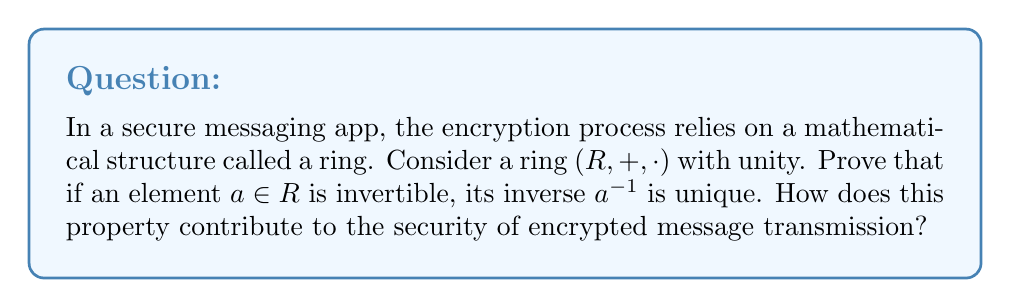Solve this math problem. Let's approach this proof step-by-step:

1) First, let's assume that $a \in R$ is invertible. This means there exists an element $b \in R$ such that $ab = ba = 1$, where $1$ is the multiplicative identity in $R$.

2) Now, let's suppose that $a$ has two inverses, call them $b$ and $c$. We need to prove that $b = c$.

3) Since $b$ is an inverse of $a$, we have:
   $ab = ba = 1$

4) Similarly, since $c$ is also an inverse of $a$:
   $ac = ca = 1$

5) Now, let's consider the product $b \cdot 1$:
   $b \cdot 1 = b \cdot (ac)$ (substituting $1$ with $ac$ from step 4)
              $= (b \cdot a) \cdot c$ (using associativity of multiplication in rings)
              $= 1 \cdot c$ (using $ba = 1$ from step 3)
              $= c$

6) Therefore, $b = c$, proving that the inverse is unique.

This uniqueness property is crucial for secure message transmission in several ways:

a) Encryption Reliability: In many encryption algorithms, the inverse operation is used for decryption. The uniqueness of inverses ensures that there's only one way to decrypt a message, preventing ambiguity.

b) Key Generation: In public-key cryptography systems often used in secure messaging, the generation of public and private keys relies on the properties of certain mathematical structures. The uniqueness of inverses in these structures ensures that each public key corresponds to exactly one private key.

c) Digital Signatures: The uniqueness of inverses is also crucial for digital signature schemes, which are often used to verify the authenticity of messages in secure communication systems.

d) Error Detection: In some cryptographic protocols, the uniqueness of inverses can be used to detect errors in transmission or tampering attempts.

For a product manager overseeing the integration of encryption in a messaging app, understanding this property helps in making informed decisions about the choice of cryptographic algorithms and in communicating the security features to users and stakeholders.
Answer: The inverse of an invertible element in a ring is unique. This property contributes to secure message transmission by ensuring encryption reliability, facilitating key generation in public-key cryptography, enabling robust digital signature schemes, and supporting error detection in cryptographic protocols. 